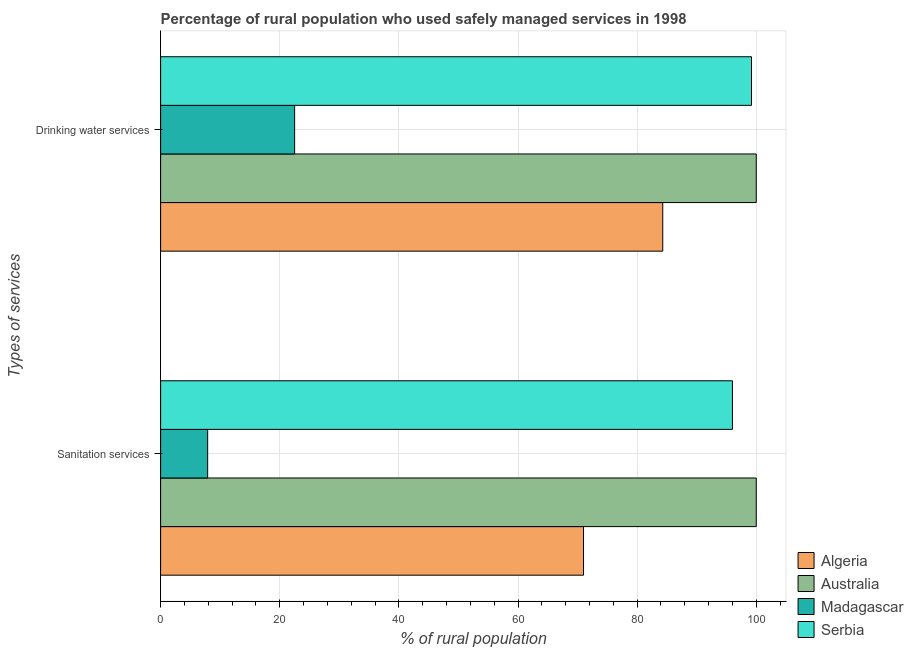How many groups of bars are there?
Ensure brevity in your answer.  2. Are the number of bars per tick equal to the number of legend labels?
Your response must be concise. Yes. What is the label of the 1st group of bars from the top?
Your answer should be very brief. Drinking water services. What is the percentage of rural population who used sanitation services in Serbia?
Offer a very short reply. 96. Across all countries, what is the maximum percentage of rural population who used drinking water services?
Give a very brief answer. 100. In which country was the percentage of rural population who used drinking water services maximum?
Offer a very short reply. Australia. In which country was the percentage of rural population who used sanitation services minimum?
Keep it short and to the point. Madagascar. What is the total percentage of rural population who used sanitation services in the graph?
Your answer should be compact. 274.9. What is the difference between the percentage of rural population who used sanitation services in Australia and that in Madagascar?
Make the answer very short. 92.1. What is the difference between the percentage of rural population who used drinking water services in Serbia and the percentage of rural population who used sanitation services in Madagascar?
Offer a very short reply. 91.3. What is the average percentage of rural population who used drinking water services per country?
Keep it short and to the point. 76.5. What is the difference between the percentage of rural population who used sanitation services and percentage of rural population who used drinking water services in Algeria?
Make the answer very short. -13.3. In how many countries, is the percentage of rural population who used drinking water services greater than 4 %?
Your answer should be compact. 4. What is the ratio of the percentage of rural population who used drinking water services in Algeria to that in Serbia?
Provide a short and direct response. 0.85. What does the 4th bar from the top in Sanitation services represents?
Your answer should be compact. Algeria. What does the 1st bar from the bottom in Sanitation services represents?
Keep it short and to the point. Algeria. How many countries are there in the graph?
Provide a succinct answer. 4. What is the difference between two consecutive major ticks on the X-axis?
Your answer should be compact. 20. Are the values on the major ticks of X-axis written in scientific E-notation?
Your answer should be very brief. No. Does the graph contain grids?
Give a very brief answer. Yes. Where does the legend appear in the graph?
Ensure brevity in your answer.  Bottom right. How are the legend labels stacked?
Your answer should be compact. Vertical. What is the title of the graph?
Offer a terse response. Percentage of rural population who used safely managed services in 1998. What is the label or title of the X-axis?
Offer a very short reply. % of rural population. What is the label or title of the Y-axis?
Make the answer very short. Types of services. What is the % of rural population in Algeria in Sanitation services?
Offer a very short reply. 71. What is the % of rural population of Australia in Sanitation services?
Give a very brief answer. 100. What is the % of rural population of Madagascar in Sanitation services?
Offer a terse response. 7.9. What is the % of rural population in Serbia in Sanitation services?
Provide a succinct answer. 96. What is the % of rural population of Algeria in Drinking water services?
Give a very brief answer. 84.3. What is the % of rural population of Australia in Drinking water services?
Offer a very short reply. 100. What is the % of rural population in Madagascar in Drinking water services?
Your response must be concise. 22.5. What is the % of rural population in Serbia in Drinking water services?
Your answer should be very brief. 99.2. Across all Types of services, what is the maximum % of rural population in Algeria?
Provide a short and direct response. 84.3. Across all Types of services, what is the maximum % of rural population in Serbia?
Ensure brevity in your answer.  99.2. Across all Types of services, what is the minimum % of rural population in Algeria?
Keep it short and to the point. 71. Across all Types of services, what is the minimum % of rural population of Madagascar?
Keep it short and to the point. 7.9. Across all Types of services, what is the minimum % of rural population of Serbia?
Your answer should be very brief. 96. What is the total % of rural population in Algeria in the graph?
Provide a short and direct response. 155.3. What is the total % of rural population in Australia in the graph?
Offer a terse response. 200. What is the total % of rural population of Madagascar in the graph?
Offer a very short reply. 30.4. What is the total % of rural population of Serbia in the graph?
Offer a terse response. 195.2. What is the difference between the % of rural population in Madagascar in Sanitation services and that in Drinking water services?
Make the answer very short. -14.6. What is the difference between the % of rural population in Algeria in Sanitation services and the % of rural population in Madagascar in Drinking water services?
Make the answer very short. 48.5. What is the difference between the % of rural population of Algeria in Sanitation services and the % of rural population of Serbia in Drinking water services?
Provide a short and direct response. -28.2. What is the difference between the % of rural population of Australia in Sanitation services and the % of rural population of Madagascar in Drinking water services?
Provide a succinct answer. 77.5. What is the difference between the % of rural population of Australia in Sanitation services and the % of rural population of Serbia in Drinking water services?
Provide a succinct answer. 0.8. What is the difference between the % of rural population in Madagascar in Sanitation services and the % of rural population in Serbia in Drinking water services?
Ensure brevity in your answer.  -91.3. What is the average % of rural population in Algeria per Types of services?
Your answer should be very brief. 77.65. What is the average % of rural population in Madagascar per Types of services?
Ensure brevity in your answer.  15.2. What is the average % of rural population of Serbia per Types of services?
Give a very brief answer. 97.6. What is the difference between the % of rural population of Algeria and % of rural population of Madagascar in Sanitation services?
Give a very brief answer. 63.1. What is the difference between the % of rural population in Australia and % of rural population in Madagascar in Sanitation services?
Your answer should be compact. 92.1. What is the difference between the % of rural population of Madagascar and % of rural population of Serbia in Sanitation services?
Offer a very short reply. -88.1. What is the difference between the % of rural population in Algeria and % of rural population in Australia in Drinking water services?
Provide a succinct answer. -15.7. What is the difference between the % of rural population in Algeria and % of rural population in Madagascar in Drinking water services?
Your response must be concise. 61.8. What is the difference between the % of rural population of Algeria and % of rural population of Serbia in Drinking water services?
Keep it short and to the point. -14.9. What is the difference between the % of rural population of Australia and % of rural population of Madagascar in Drinking water services?
Keep it short and to the point. 77.5. What is the difference between the % of rural population in Madagascar and % of rural population in Serbia in Drinking water services?
Provide a short and direct response. -76.7. What is the ratio of the % of rural population of Algeria in Sanitation services to that in Drinking water services?
Provide a short and direct response. 0.84. What is the ratio of the % of rural population of Madagascar in Sanitation services to that in Drinking water services?
Your response must be concise. 0.35. What is the ratio of the % of rural population of Serbia in Sanitation services to that in Drinking water services?
Give a very brief answer. 0.97. What is the difference between the highest and the second highest % of rural population of Algeria?
Your response must be concise. 13.3. What is the difference between the highest and the second highest % of rural population in Australia?
Provide a succinct answer. 0. What is the difference between the highest and the second highest % of rural population in Madagascar?
Ensure brevity in your answer.  14.6. What is the difference between the highest and the lowest % of rural population in Madagascar?
Offer a very short reply. 14.6. What is the difference between the highest and the lowest % of rural population in Serbia?
Offer a very short reply. 3.2. 